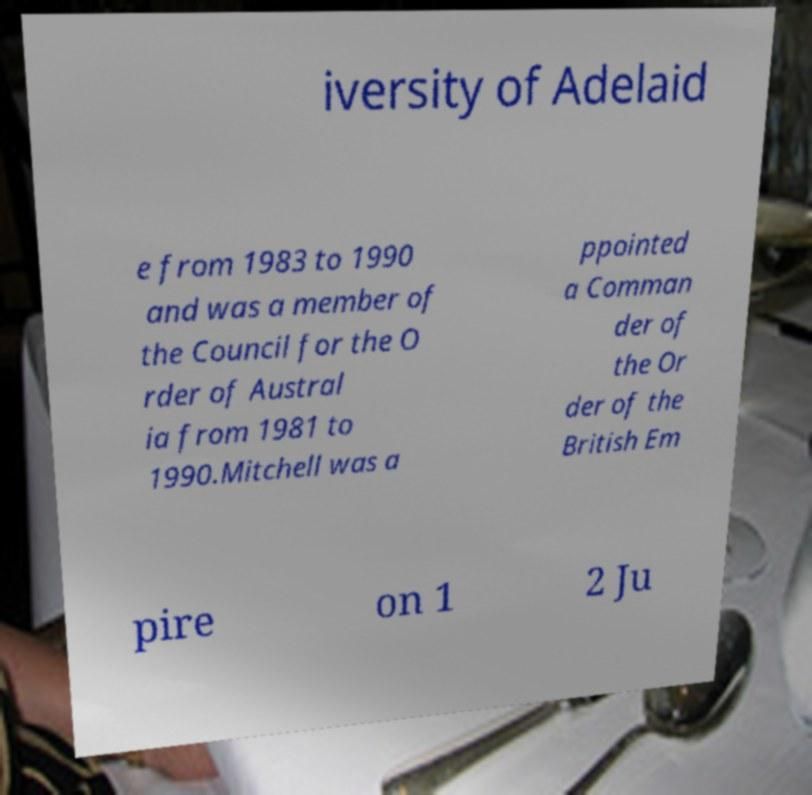There's text embedded in this image that I need extracted. Can you transcribe it verbatim? iversity of Adelaid e from 1983 to 1990 and was a member of the Council for the O rder of Austral ia from 1981 to 1990.Mitchell was a ppointed a Comman der of the Or der of the British Em pire on 1 2 Ju 